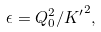<formula> <loc_0><loc_0><loc_500><loc_500>\epsilon = Q _ { 0 } ^ { 2 } / { K ^ { \prime } } ^ { 2 } ,</formula> 